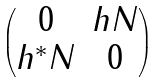Convert formula to latex. <formula><loc_0><loc_0><loc_500><loc_500>\begin{pmatrix} 0 & h N \\ h ^ { * } N & 0 \end{pmatrix}</formula> 